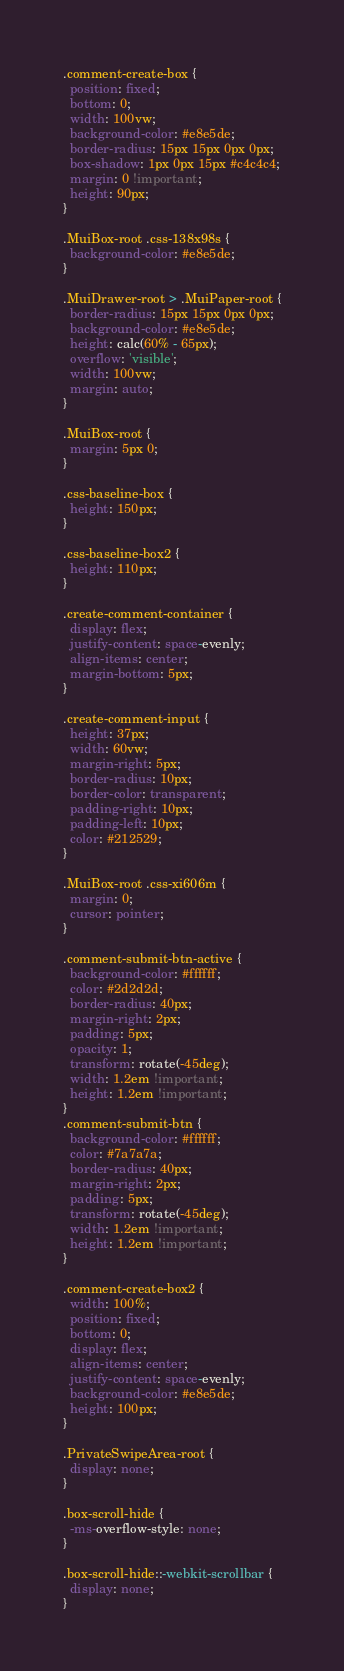<code> <loc_0><loc_0><loc_500><loc_500><_CSS_>.comment-create-box {
  position: fixed;
  bottom: 0;
  width: 100vw;
  background-color: #e8e5de;
  border-radius: 15px 15px 0px 0px;
  box-shadow: 1px 0px 15px #c4c4c4;
  margin: 0 !important;
  height: 90px;
}

.MuiBox-root .css-138x98s {
  background-color: #e8e5de;
}

.MuiDrawer-root > .MuiPaper-root {
  border-radius: 15px 15px 0px 0px;
  background-color: #e8e5de;
  height: calc(60% - 65px);
  overflow: 'visible';
  width: 100vw;
  margin: auto;
}

.MuiBox-root {
  margin: 5px 0;
}

.css-baseline-box {
  height: 150px;
}

.css-baseline-box2 {
  height: 110px;
}

.create-comment-container {
  display: flex;
  justify-content: space-evenly;
  align-items: center;
  margin-bottom: 5px;
}

.create-comment-input {
  height: 37px;
  width: 60vw;
  margin-right: 5px;
  border-radius: 10px;
  border-color: transparent;
  padding-right: 10px;
  padding-left: 10px;
  color: #212529;
}

.MuiBox-root .css-xi606m {
  margin: 0;
  cursor: pointer;
}

.comment-submit-btn-active {
  background-color: #ffffff;
  color: #2d2d2d;
  border-radius: 40px;
  margin-right: 2px;
  padding: 5px;
  opacity: 1;
  transform: rotate(-45deg);
  width: 1.2em !important;
  height: 1.2em !important;
}
.comment-submit-btn {
  background-color: #ffffff;
  color: #7a7a7a;
  border-radius: 40px;
  margin-right: 2px;
  padding: 5px;
  transform: rotate(-45deg);
  width: 1.2em !important;
  height: 1.2em !important;
}

.comment-create-box2 {
  width: 100%;
  position: fixed;
  bottom: 0;
  display: flex;
  align-items: center;
  justify-content: space-evenly;
  background-color: #e8e5de;
  height: 100px;
}

.PrivateSwipeArea-root {
  display: none;
}

.box-scroll-hide {
  -ms-overflow-style: none;
}

.box-scroll-hide::-webkit-scrollbar {
  display: none;
}
</code> 